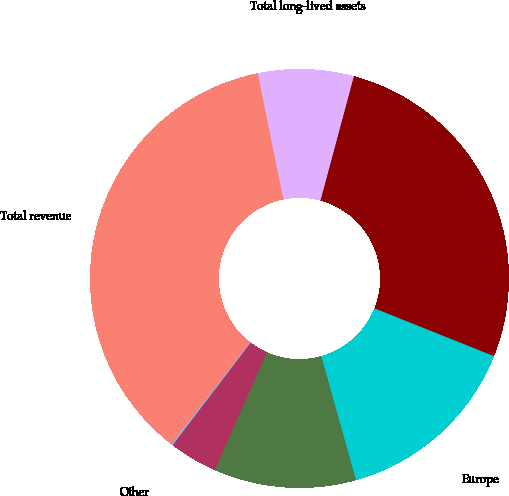Convert chart to OTSL. <chart><loc_0><loc_0><loc_500><loc_500><pie_chart><fcel>United States<fcel>Europe<fcel>Canada<fcel>China<fcel>Other<fcel>Total revenue<fcel>Total long-lived assets<nl><fcel>26.88%<fcel>14.6%<fcel>10.98%<fcel>3.73%<fcel>0.11%<fcel>36.34%<fcel>7.36%<nl></chart> 